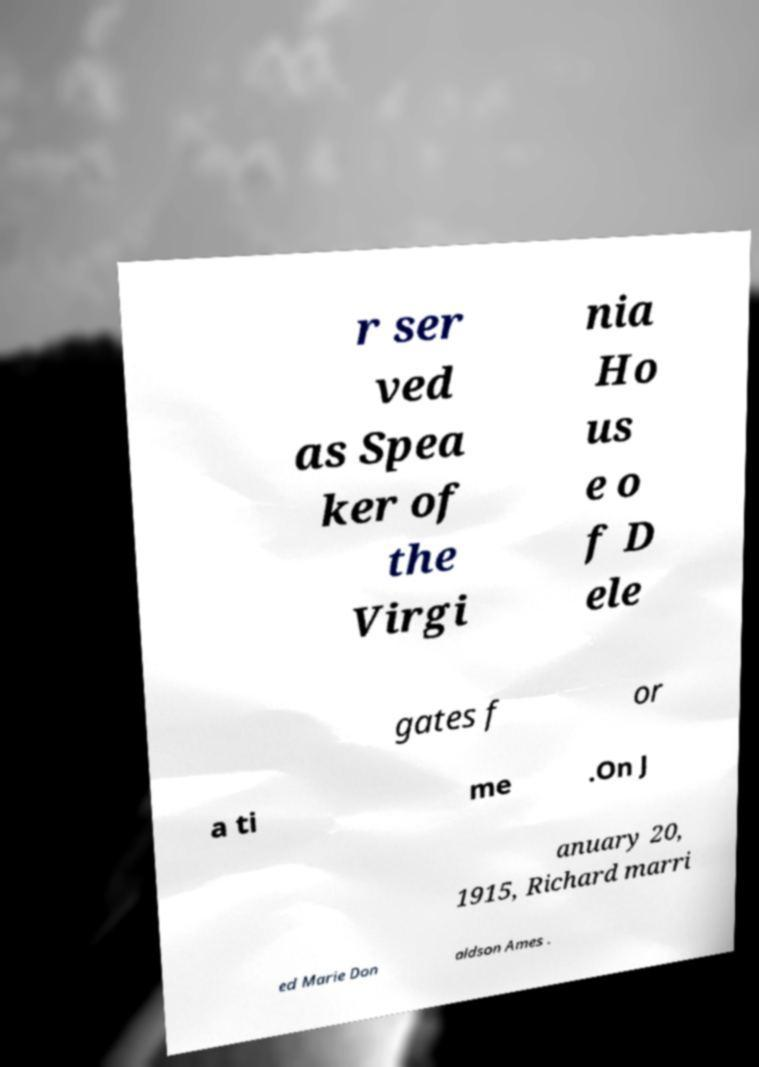For documentation purposes, I need the text within this image transcribed. Could you provide that? r ser ved as Spea ker of the Virgi nia Ho us e o f D ele gates f or a ti me .On J anuary 20, 1915, Richard marri ed Marie Don aldson Ames . 